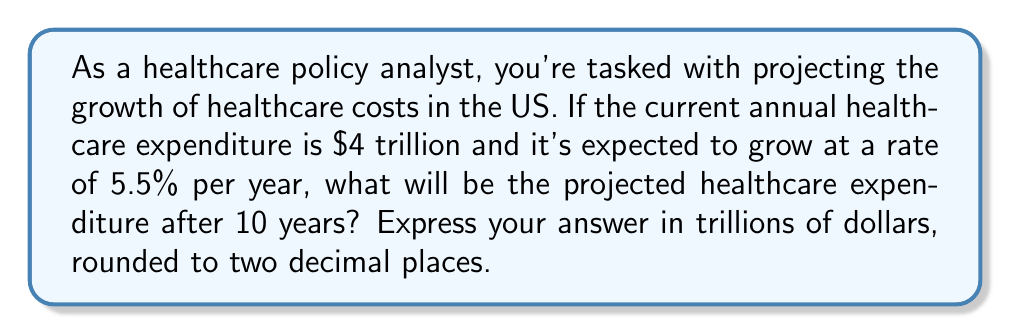What is the answer to this math problem? To solve this problem, we'll use the exponential growth formula:

$$ A = P(1 + r)^t $$

Where:
$A$ = Final amount
$P$ = Initial principal balance
$r$ = Annual growth rate (as a decimal)
$t$ = Number of years

Given:
$P = 4$ trillion dollars
$r = 5.5\% = 0.055$
$t = 10$ years

Let's substitute these values into the formula:

$$ A = 4(1 + 0.055)^{10} $$

Now, let's calculate step by step:

1) First, calculate $(1 + 0.055)$:
   $1 + 0.055 = 1.055$

2) Now, raise this to the power of 10:
   $1.055^{10} \approx 1.7081$

3) Finally, multiply by the initial amount:
   $4 \times 1.7081 \approx 6.8324$

Therefore, the projected healthcare expenditure after 10 years will be approximately $6.83 trillion.
Answer: $6.83 trillion 